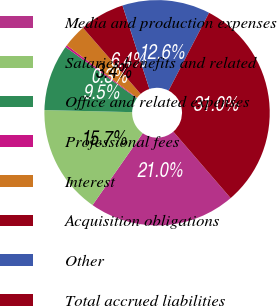Convert chart. <chart><loc_0><loc_0><loc_500><loc_500><pie_chart><fcel>Media and production expenses<fcel>Salaries benefits and related<fcel>Office and related expenses<fcel>Professional fees<fcel>Interest<fcel>Acquisition obligations<fcel>Other<fcel>Total accrued liabilities<nl><fcel>21.03%<fcel>15.67%<fcel>9.53%<fcel>0.3%<fcel>3.38%<fcel>6.45%<fcel>12.6%<fcel>31.04%<nl></chart> 